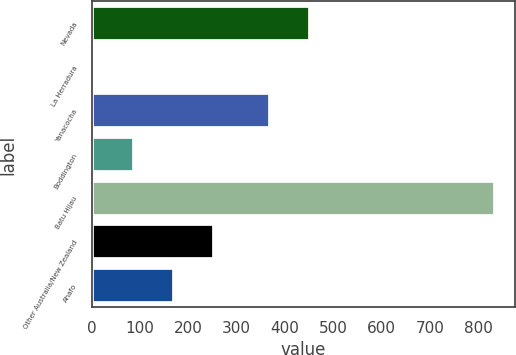Convert chart. <chart><loc_0><loc_0><loc_500><loc_500><bar_chart><fcel>Nevada<fcel>La Herradura<fcel>Yanacocha<fcel>Boddington<fcel>Batu Hijau<fcel>Other Australia/New Zealand<fcel>Ahafo<nl><fcel>451.9<fcel>5<fcel>369<fcel>87.9<fcel>834<fcel>253.7<fcel>170.8<nl></chart> 